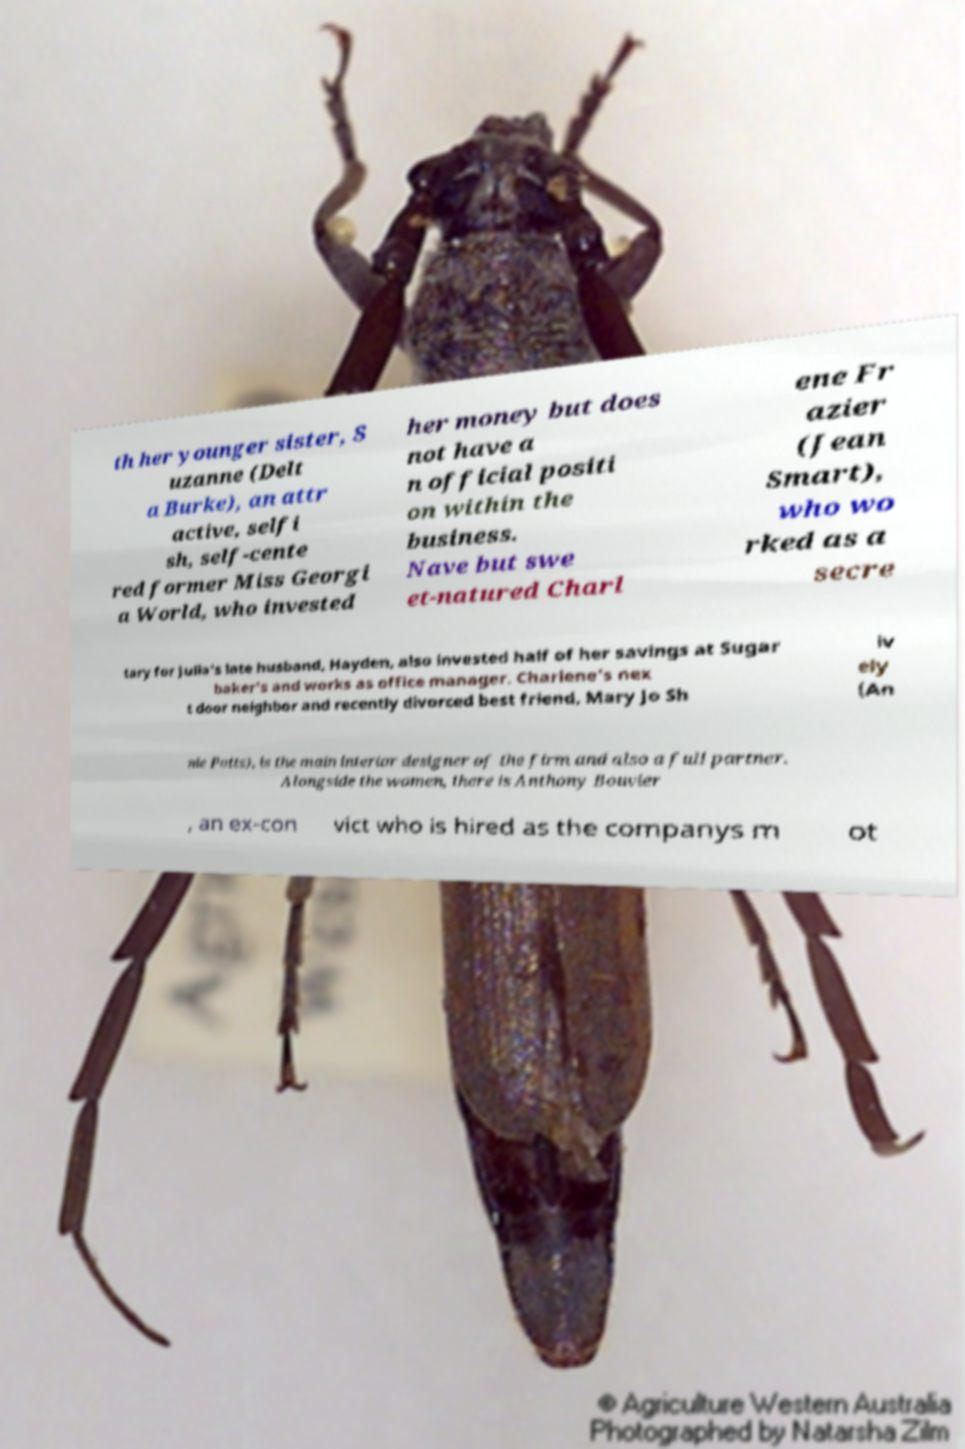Please read and relay the text visible in this image. What does it say? th her younger sister, S uzanne (Delt a Burke), an attr active, selfi sh, self-cente red former Miss Georgi a World, who invested her money but does not have a n official positi on within the business. Nave but swe et-natured Charl ene Fr azier (Jean Smart), who wo rked as a secre tary for Julia's late husband, Hayden, also invested half of her savings at Sugar baker's and works as office manager. Charlene's nex t door neighbor and recently divorced best friend, Mary Jo Sh iv ely (An nie Potts), is the main interior designer of the firm and also a full partner. Alongside the women, there is Anthony Bouvier , an ex-con vict who is hired as the companys m ot 